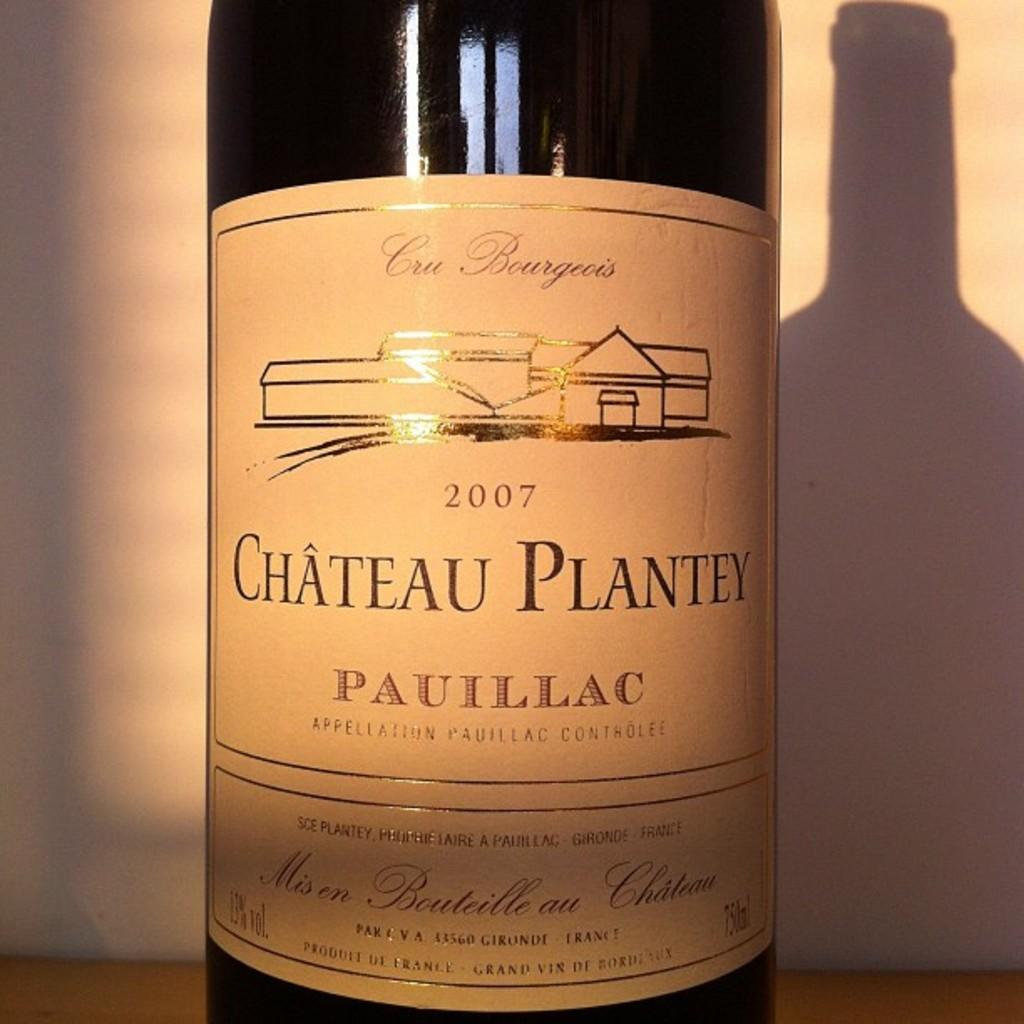<image>
Relay a brief, clear account of the picture shown. the word chateau that is on a wine bottle 